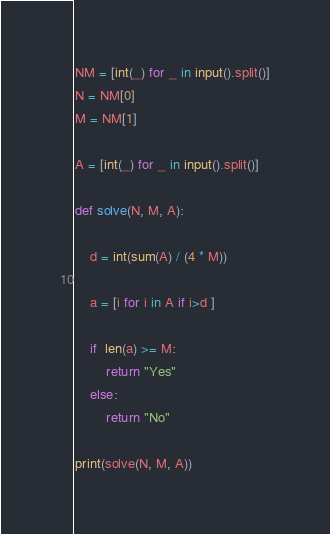<code> <loc_0><loc_0><loc_500><loc_500><_Python_>NM = [int(_) for _ in input().split()]
N = NM[0]
M = NM[1]

A = [int(_) for _ in input().split()]

def solve(N, M, A):
    
    d = int(sum(A) / (4 * M))
    
    a = [i for i in A if i>d ]
    
    if  len(a) >= M:
        return "Yes"
    else:
        return "No"

print(solve(N, M, A))</code> 